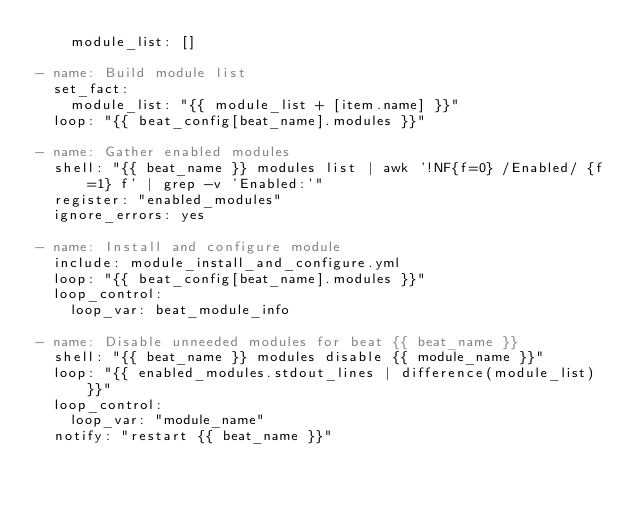<code> <loc_0><loc_0><loc_500><loc_500><_YAML_>    module_list: []

- name: Build module list
  set_fact:
    module_list: "{{ module_list + [item.name] }}"
  loop: "{{ beat_config[beat_name].modules }}"

- name: Gather enabled modules
  shell: "{{ beat_name }} modules list | awk '!NF{f=0} /Enabled/ {f=1} f' | grep -v 'Enabled:'"
  register: "enabled_modules"
  ignore_errors: yes

- name: Install and configure module
  include: module_install_and_configure.yml
  loop: "{{ beat_config[beat_name].modules }}"
  loop_control:
    loop_var: beat_module_info

- name: Disable unneeded modules for beat {{ beat_name }}
  shell: "{{ beat_name }} modules disable {{ module_name }}"
  loop: "{{ enabled_modules.stdout_lines | difference(module_list) }}"
  loop_control:
    loop_var: "module_name"
  notify: "restart {{ beat_name }}"
</code> 